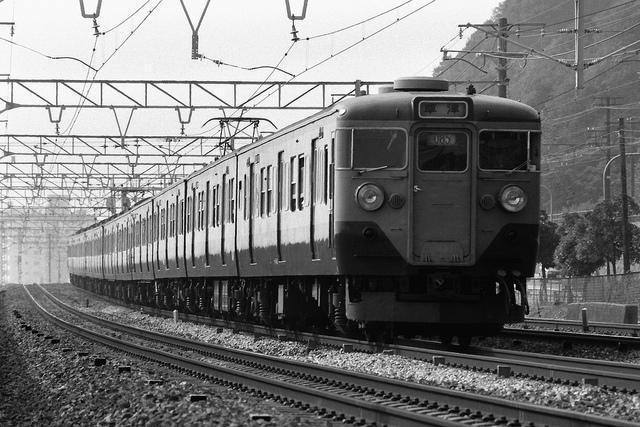How many people are doing a frontside bluntslide down a rail?
Give a very brief answer. 0. 